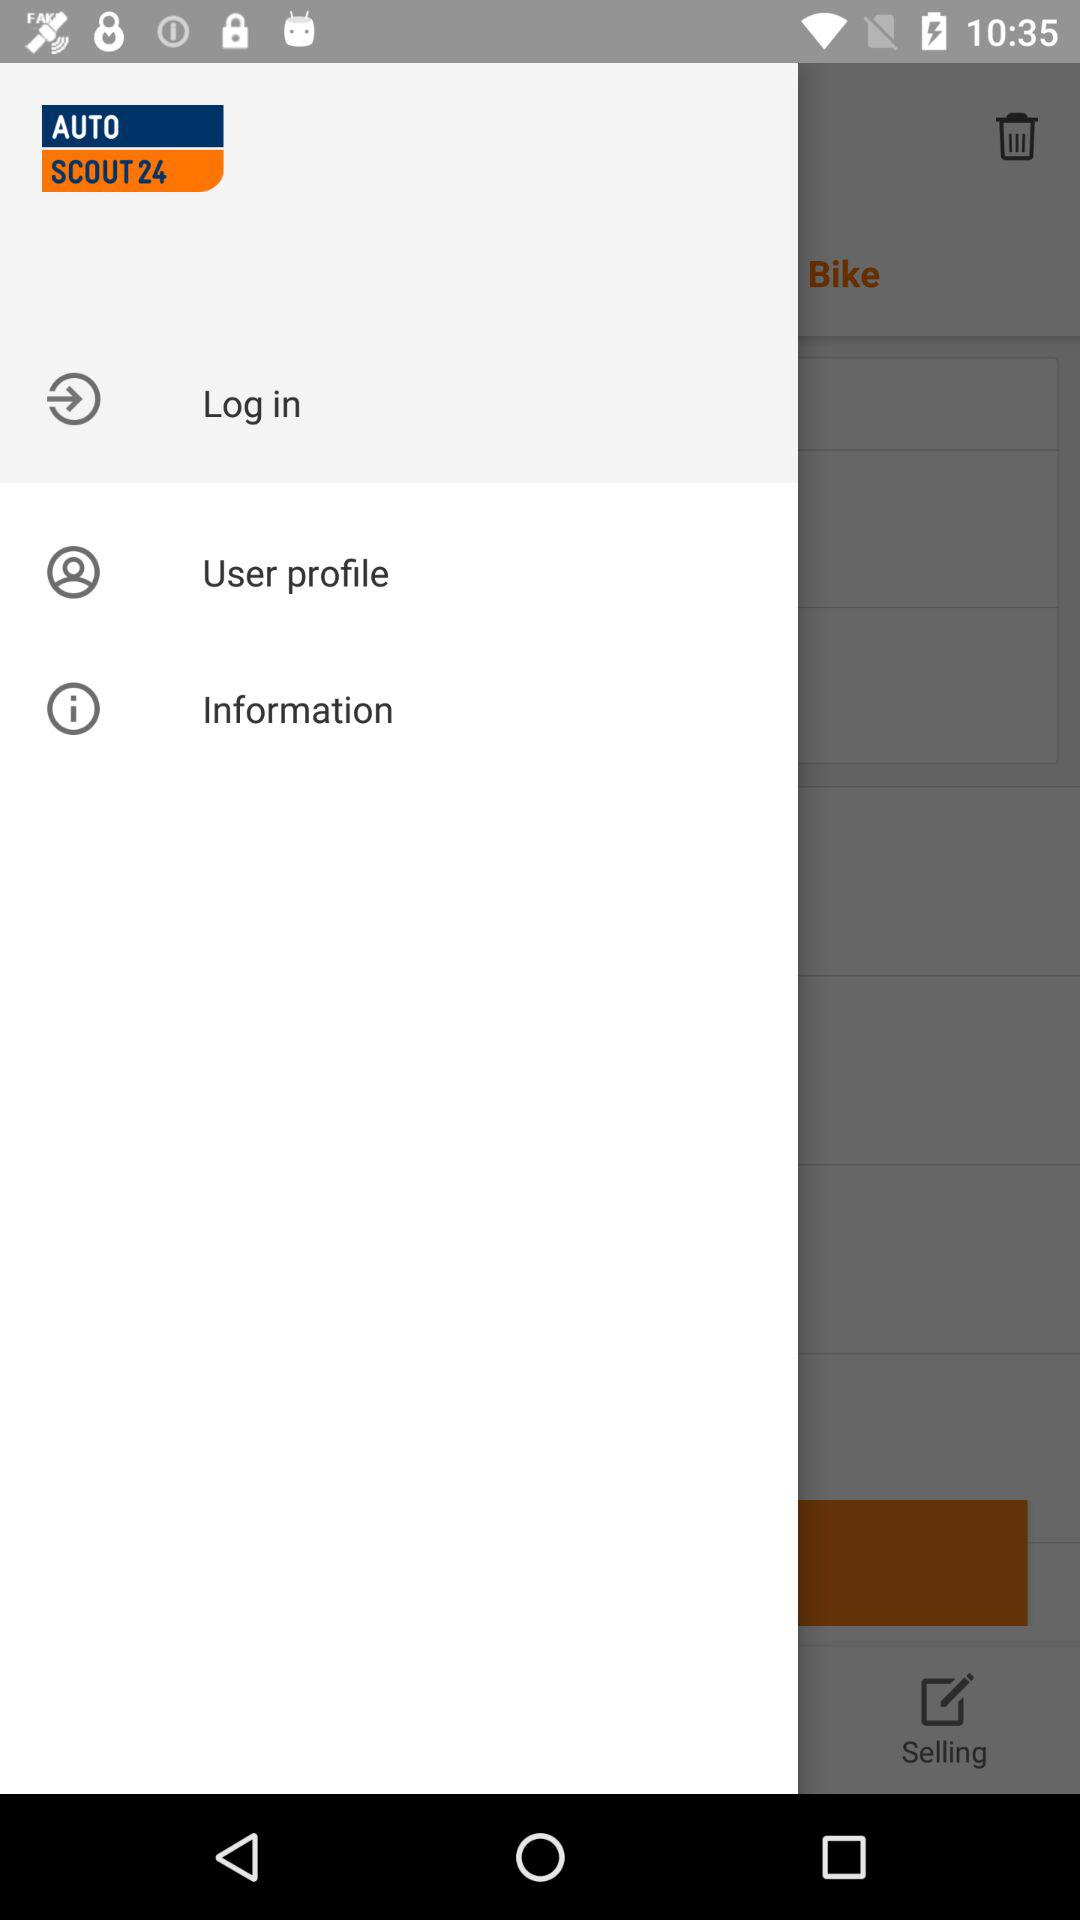What is the name of the application? The name of the application is "AUTO SCOUT 24". 